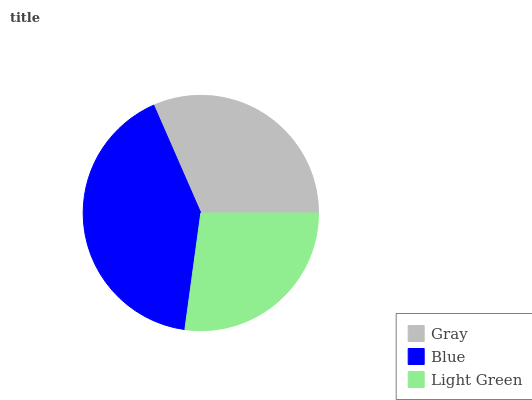Is Light Green the minimum?
Answer yes or no. Yes. Is Blue the maximum?
Answer yes or no. Yes. Is Blue the minimum?
Answer yes or no. No. Is Light Green the maximum?
Answer yes or no. No. Is Blue greater than Light Green?
Answer yes or no. Yes. Is Light Green less than Blue?
Answer yes or no. Yes. Is Light Green greater than Blue?
Answer yes or no. No. Is Blue less than Light Green?
Answer yes or no. No. Is Gray the high median?
Answer yes or no. Yes. Is Gray the low median?
Answer yes or no. Yes. Is Light Green the high median?
Answer yes or no. No. Is Light Green the low median?
Answer yes or no. No. 